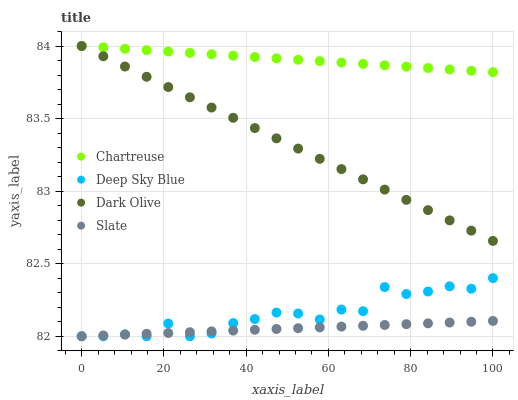Does Slate have the minimum area under the curve?
Answer yes or no. Yes. Does Chartreuse have the maximum area under the curve?
Answer yes or no. Yes. Does Dark Olive have the minimum area under the curve?
Answer yes or no. No. Does Dark Olive have the maximum area under the curve?
Answer yes or no. No. Is Dark Olive the smoothest?
Answer yes or no. Yes. Is Deep Sky Blue the roughest?
Answer yes or no. Yes. Is Slate the smoothest?
Answer yes or no. No. Is Slate the roughest?
Answer yes or no. No. Does Slate have the lowest value?
Answer yes or no. Yes. Does Dark Olive have the lowest value?
Answer yes or no. No. Does Dark Olive have the highest value?
Answer yes or no. Yes. Does Slate have the highest value?
Answer yes or no. No. Is Slate less than Dark Olive?
Answer yes or no. Yes. Is Dark Olive greater than Deep Sky Blue?
Answer yes or no. Yes. Does Deep Sky Blue intersect Slate?
Answer yes or no. Yes. Is Deep Sky Blue less than Slate?
Answer yes or no. No. Is Deep Sky Blue greater than Slate?
Answer yes or no. No. Does Slate intersect Dark Olive?
Answer yes or no. No. 